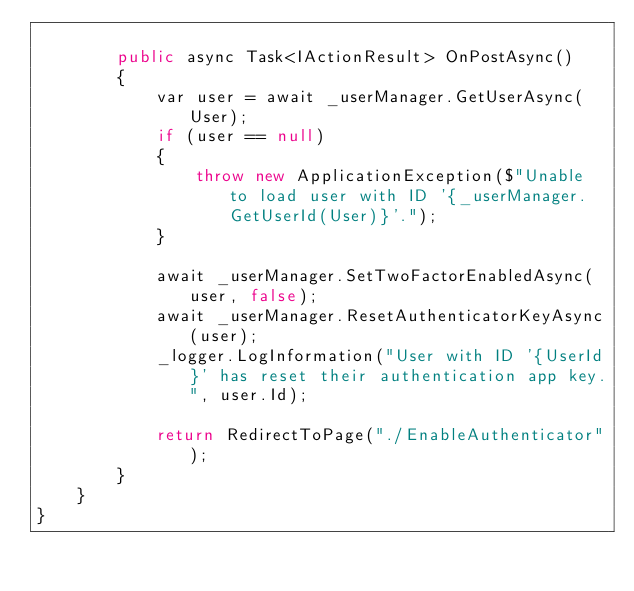Convert code to text. <code><loc_0><loc_0><loc_500><loc_500><_C#_>
        public async Task<IActionResult> OnPostAsync()
        {
            var user = await _userManager.GetUserAsync(User);
            if (user == null)
            {
                throw new ApplicationException($"Unable to load user with ID '{_userManager.GetUserId(User)}'.");
            }

            await _userManager.SetTwoFactorEnabledAsync(user, false);
            await _userManager.ResetAuthenticatorKeyAsync(user);
            _logger.LogInformation("User with ID '{UserId}' has reset their authentication app key.", user.Id);

            return RedirectToPage("./EnableAuthenticator");
        }
    }
}</code> 